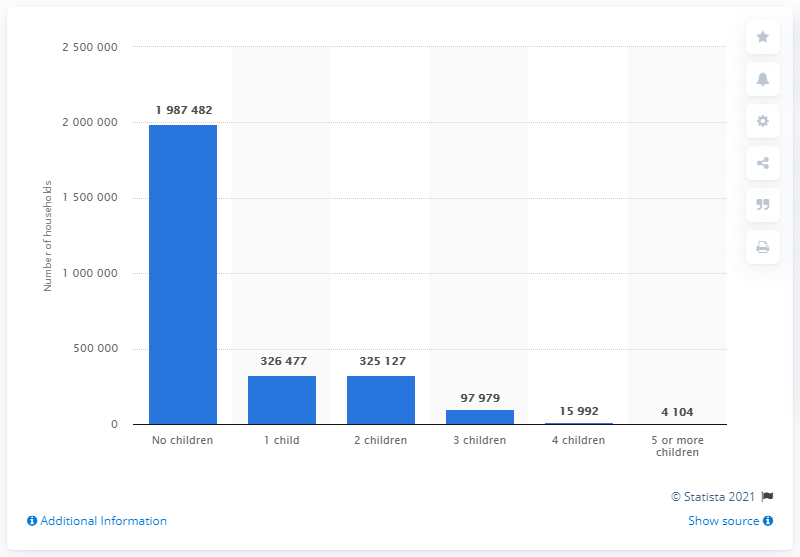Indicate a few pertinent items in this graphic. In 2021, there were approximately 325,127 households in the United States that contained one child. 